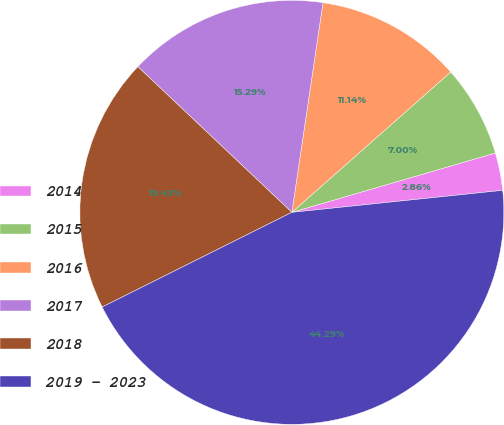Convert chart. <chart><loc_0><loc_0><loc_500><loc_500><pie_chart><fcel>2014<fcel>2015<fcel>2016<fcel>2017<fcel>2018<fcel>2019 - 2023<nl><fcel>2.86%<fcel>7.0%<fcel>11.14%<fcel>15.29%<fcel>19.43%<fcel>44.29%<nl></chart> 